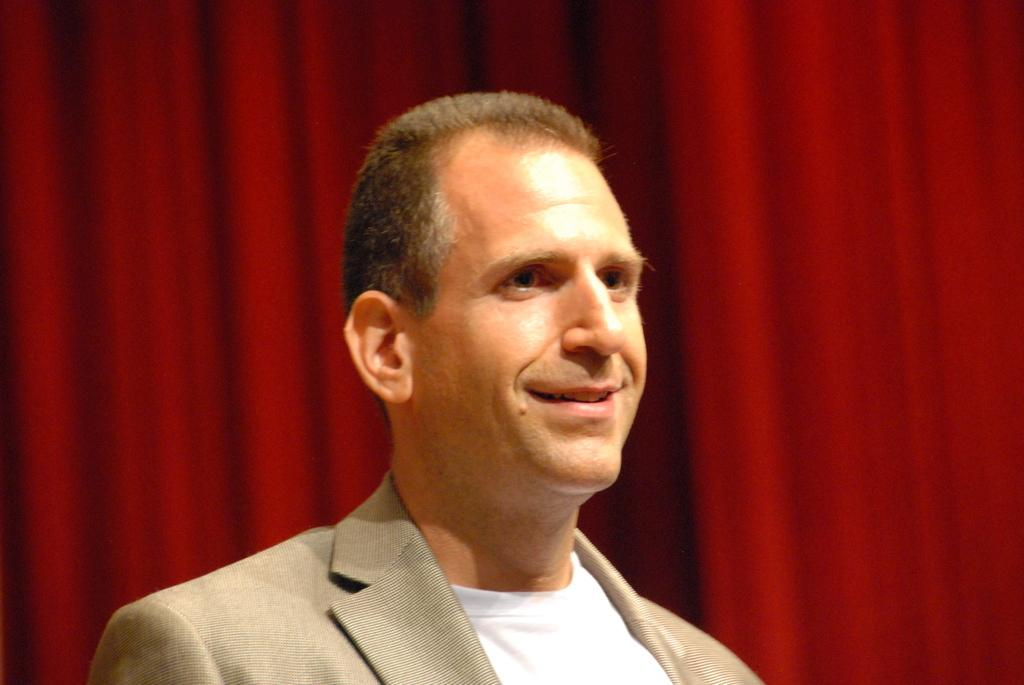What is the person in the image wearing? The person in the image is wearing a suit. What expression does the person have? The person is smiling. What color is the background of the image? The background of the image is red. What type of vegetable is being harvested in the background of the image? There is no vegetable or harvesting activity present in the image; the background is simply red. 